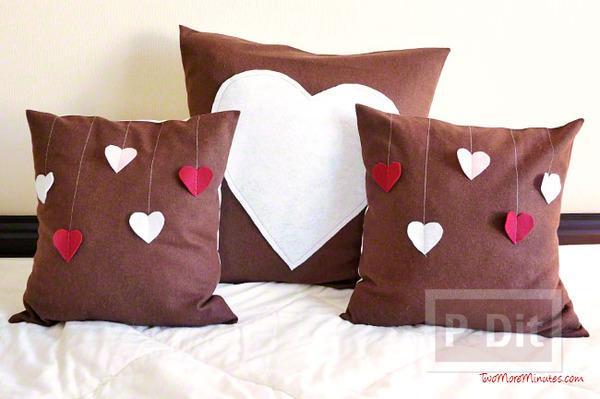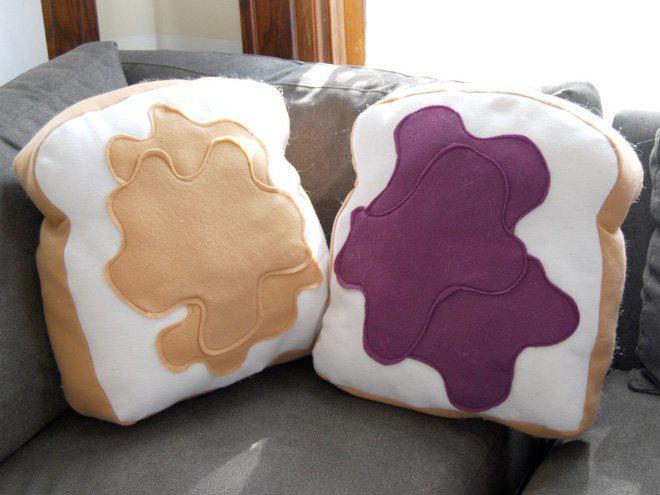The first image is the image on the left, the second image is the image on the right. For the images displayed, is the sentence "An image includes at least one pillow shaped like a slice of bread." factually correct? Answer yes or no. Yes. 